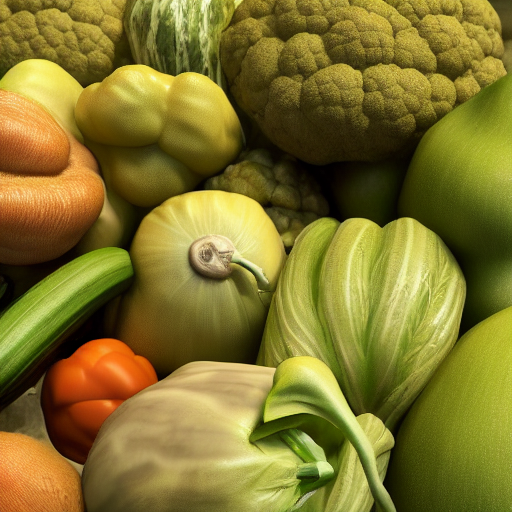Is the composition of the image interesting? Yes, the image presents an intriguing composition with a variety of vegetables tightly arranged to create a visually appealing patchwork of colors and textures. The presence of a snail adds an element of surprise and animate contrast to the otherwise still life, thereby capturing the viewer's interest. 